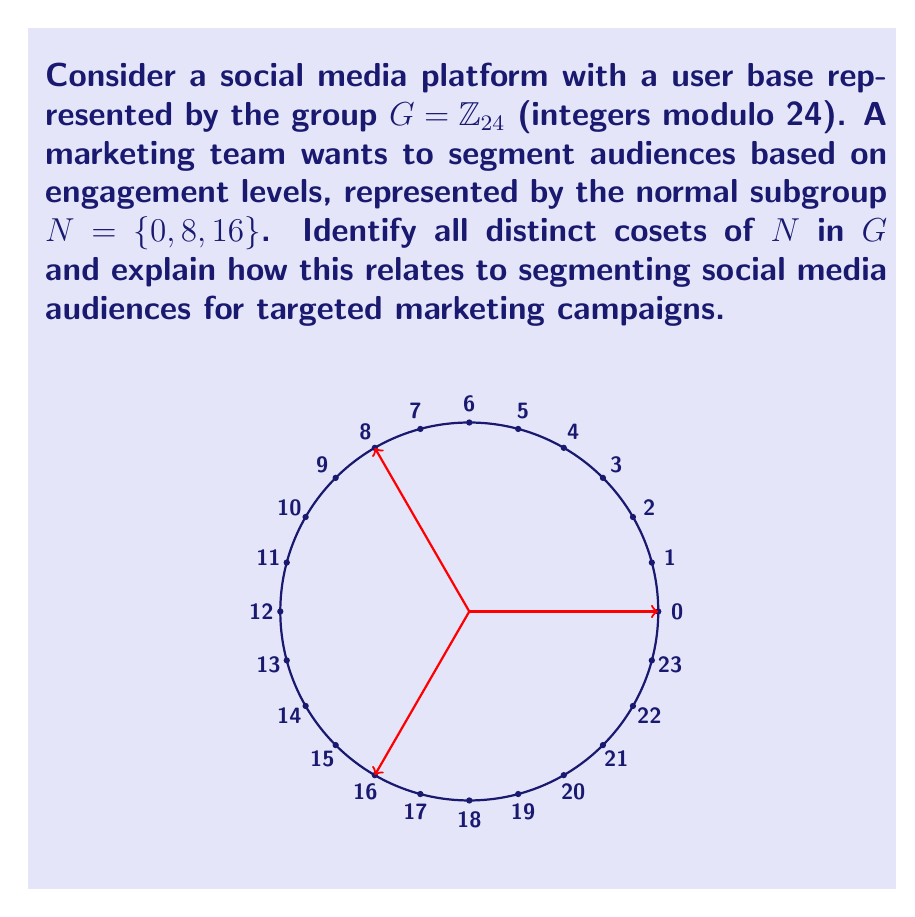What is the answer to this math problem? To solve this problem, we'll follow these steps:

1) First, recall that for a normal subgroup $N$ of $G$, the cosets of $N$ in $G$ are the sets of the form $gN = \{gn : n \in N\}$ for each $g \in G$.

2) In this case, $N = \{0, 8, 16\}$. We need to find all distinct cosets of $N$ in $G$.

3) Let's calculate the cosets:

   For $g = 0$: $0 + N = \{0, 8, 16\}$
   For $g = 1$: $1 + N = \{1, 9, 17\}$
   For $g = 2$: $2 + N = \{2, 10, 18\}$
   For $g = 3$: $3 + N = \{3, 11, 19\}$
   For $g = 4$: $4 + N = \{4, 12, 20\}$
   For $g = 5$: $5 + N = \{5, 13, 21\}$
   For $g = 6$: $6 + N = \{6, 14, 22\}$
   For $g = 7$: $7 + N = \{7, 15, 23\}$

4) Notice that the coset for $g = 8$ is the same as for $g = 0$, and this pattern repeats every 8 steps. This is because $|G|/|N| = 24/3 = 8$.

5) Therefore, there are 8 distinct cosets of $N$ in $G$.

6) In the context of social media audience segmentation:
   - Each coset represents a distinct segment of the audience.
   - The elements within each coset represent users with similar engagement levels or behaviors.
   - The 8 segments allow for more targeted marketing campaigns, as users within the same segment are likely to respond similarly to marketing efforts.
   - This segmentation enables the social media specialist to tailor content and ad strategies for each group, potentially improving website conversion rates.
Answer: $\{0, 8, 16\}, \{1, 9, 17\}, \{2, 10, 18\}, \{3, 11, 19\}, \{4, 12, 20\}, \{5, 13, 21\}, \{6, 14, 22\}, \{7, 15, 23\}$ 